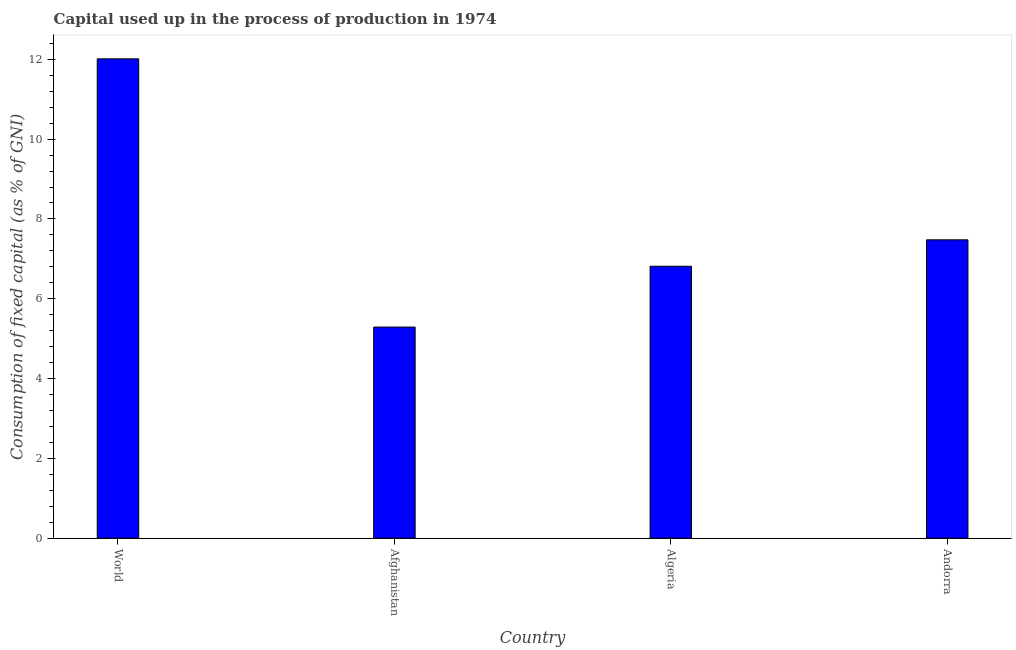Does the graph contain any zero values?
Offer a very short reply. No. Does the graph contain grids?
Your response must be concise. No. What is the title of the graph?
Offer a very short reply. Capital used up in the process of production in 1974. What is the label or title of the Y-axis?
Your response must be concise. Consumption of fixed capital (as % of GNI). What is the consumption of fixed capital in World?
Provide a succinct answer. 12.01. Across all countries, what is the maximum consumption of fixed capital?
Provide a short and direct response. 12.01. Across all countries, what is the minimum consumption of fixed capital?
Give a very brief answer. 5.29. In which country was the consumption of fixed capital maximum?
Keep it short and to the point. World. In which country was the consumption of fixed capital minimum?
Keep it short and to the point. Afghanistan. What is the sum of the consumption of fixed capital?
Offer a very short reply. 31.6. What is the difference between the consumption of fixed capital in Algeria and Andorra?
Ensure brevity in your answer.  -0.66. What is the average consumption of fixed capital per country?
Give a very brief answer. 7.9. What is the median consumption of fixed capital?
Give a very brief answer. 7.15. What is the ratio of the consumption of fixed capital in Algeria to that in World?
Your answer should be very brief. 0.57. Is the consumption of fixed capital in Andorra less than that in World?
Ensure brevity in your answer.  Yes. What is the difference between the highest and the second highest consumption of fixed capital?
Keep it short and to the point. 4.53. Is the sum of the consumption of fixed capital in Algeria and World greater than the maximum consumption of fixed capital across all countries?
Give a very brief answer. Yes. What is the difference between the highest and the lowest consumption of fixed capital?
Make the answer very short. 6.72. Are all the bars in the graph horizontal?
Ensure brevity in your answer.  No. How many countries are there in the graph?
Your answer should be compact. 4. Are the values on the major ticks of Y-axis written in scientific E-notation?
Your answer should be compact. No. What is the Consumption of fixed capital (as % of GNI) in World?
Make the answer very short. 12.01. What is the Consumption of fixed capital (as % of GNI) of Afghanistan?
Keep it short and to the point. 5.29. What is the Consumption of fixed capital (as % of GNI) of Algeria?
Provide a succinct answer. 6.82. What is the Consumption of fixed capital (as % of GNI) in Andorra?
Provide a short and direct response. 7.48. What is the difference between the Consumption of fixed capital (as % of GNI) in World and Afghanistan?
Your answer should be compact. 6.72. What is the difference between the Consumption of fixed capital (as % of GNI) in World and Algeria?
Ensure brevity in your answer.  5.2. What is the difference between the Consumption of fixed capital (as % of GNI) in World and Andorra?
Give a very brief answer. 4.53. What is the difference between the Consumption of fixed capital (as % of GNI) in Afghanistan and Algeria?
Offer a terse response. -1.52. What is the difference between the Consumption of fixed capital (as % of GNI) in Afghanistan and Andorra?
Ensure brevity in your answer.  -2.19. What is the difference between the Consumption of fixed capital (as % of GNI) in Algeria and Andorra?
Your answer should be compact. -0.66. What is the ratio of the Consumption of fixed capital (as % of GNI) in World to that in Afghanistan?
Make the answer very short. 2.27. What is the ratio of the Consumption of fixed capital (as % of GNI) in World to that in Algeria?
Offer a terse response. 1.76. What is the ratio of the Consumption of fixed capital (as % of GNI) in World to that in Andorra?
Your response must be concise. 1.61. What is the ratio of the Consumption of fixed capital (as % of GNI) in Afghanistan to that in Algeria?
Make the answer very short. 0.78. What is the ratio of the Consumption of fixed capital (as % of GNI) in Afghanistan to that in Andorra?
Make the answer very short. 0.71. What is the ratio of the Consumption of fixed capital (as % of GNI) in Algeria to that in Andorra?
Offer a terse response. 0.91. 